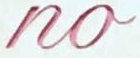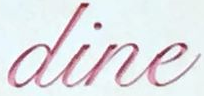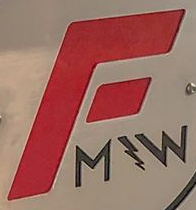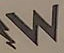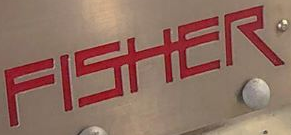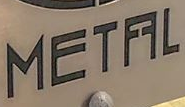Read the text from these images in sequence, separated by a semicolon. no; dine; F; W; FISHER; METFFL 